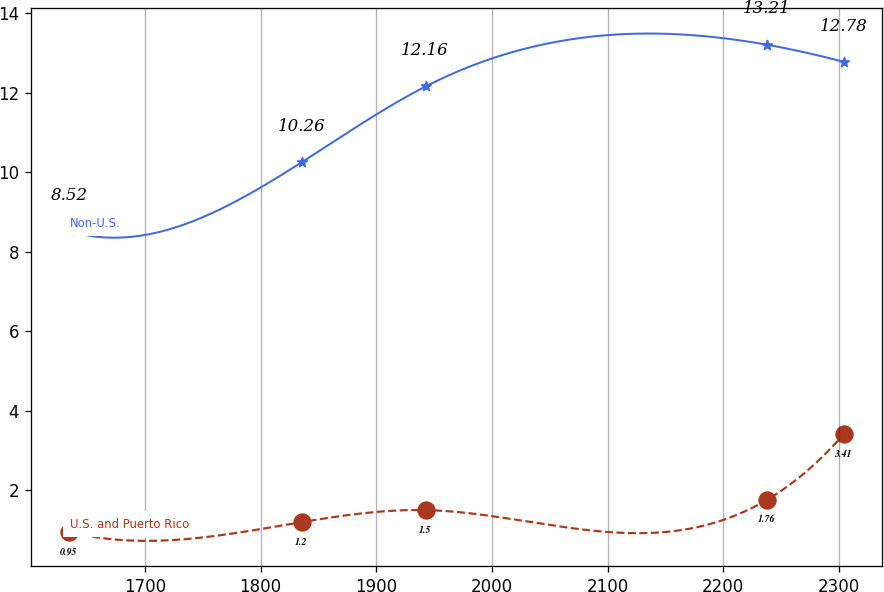Convert chart to OTSL. <chart><loc_0><loc_0><loc_500><loc_500><line_chart><ecel><fcel>U.S. and Puerto Rico<fcel>Non-U.S.<nl><fcel>1634.81<fcel>0.95<fcel>8.52<nl><fcel>1835.9<fcel>1.2<fcel>10.26<nl><fcel>1942.65<fcel>1.5<fcel>12.16<nl><fcel>2237.78<fcel>1.76<fcel>13.21<nl><fcel>2304.1<fcel>3.41<fcel>12.78<nl></chart> 